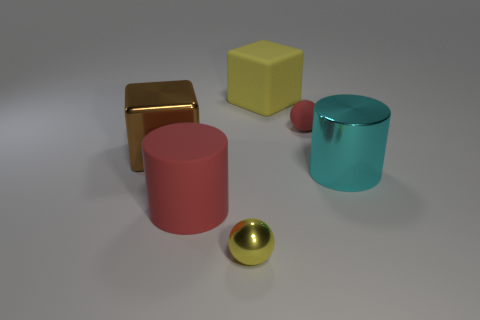What is the material of the yellow object behind the cyan metal cylinder?
Ensure brevity in your answer.  Rubber. Do the tiny object that is behind the big cyan cylinder and the big object behind the tiny red ball have the same material?
Your answer should be compact. Yes. Are there an equal number of small red matte spheres that are in front of the cyan object and large red matte cylinders to the left of the tiny yellow object?
Keep it short and to the point. No. What number of brown blocks are the same material as the cyan cylinder?
Offer a terse response. 1. The metal thing that is the same color as the matte block is what shape?
Offer a very short reply. Sphere. How big is the block that is to the left of the big thing that is in front of the big cyan cylinder?
Your answer should be compact. Large. Is the shape of the red rubber thing that is left of the tiny rubber ball the same as the big metallic object that is to the right of the small metal ball?
Give a very brief answer. Yes. Is the number of tiny yellow balls to the right of the tiny yellow shiny object the same as the number of big shiny cubes?
Provide a short and direct response. No. There is another small object that is the same shape as the tiny yellow shiny object; what color is it?
Give a very brief answer. Red. Is the material of the small sphere right of the yellow cube the same as the brown block?
Your response must be concise. No. 